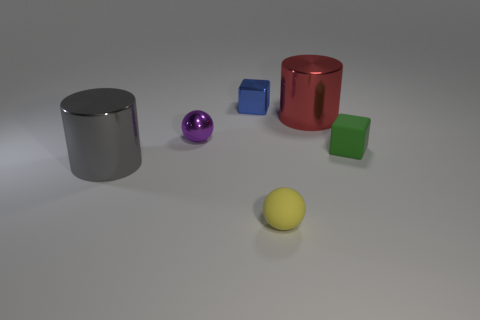Add 2 small things. How many objects exist? 8 Subtract all cylinders. How many objects are left? 4 Subtract all green rubber balls. Subtract all blue shiny cubes. How many objects are left? 5 Add 1 gray cylinders. How many gray cylinders are left? 2 Add 5 metallic cylinders. How many metallic cylinders exist? 7 Subtract 0 brown cylinders. How many objects are left? 6 